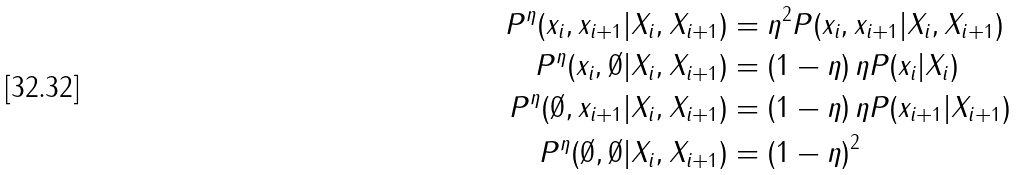<formula> <loc_0><loc_0><loc_500><loc_500>P ^ { \eta } ( x _ { i } , x _ { i + 1 } | X _ { i } , X _ { i + 1 } ) & = \eta ^ { 2 } P ( x _ { i } , x _ { i + 1 } | X _ { i } , X _ { i + 1 } ) \\ P ^ { \eta } ( x _ { i } , \emptyset | X _ { i } , X _ { i + 1 } ) & = \left ( 1 - \eta \right ) \eta P ( x _ { i } | X _ { i } ) \\ P ^ { \eta } ( \emptyset , x _ { i + 1 } | X _ { i } , X _ { i + 1 } ) & = \left ( 1 - \eta \right ) \eta P ( x _ { i + 1 } | X _ { i + 1 } ) \\ P ^ { \eta } ( \emptyset , \emptyset | X _ { i } , X _ { i + 1 } ) & = \left ( 1 - \eta \right ) ^ { 2 }</formula> 